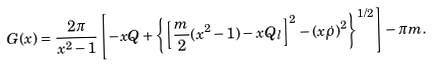Convert formula to latex. <formula><loc_0><loc_0><loc_500><loc_500>G ( x ) = \frac { 2 \pi } { x ^ { 2 } - 1 } \left [ - x Q + \left \{ \left [ \frac { m } { 2 } ( x ^ { 2 } - 1 ) - x Q _ { l } \right ] ^ { 2 } - ( x \dot { \rho } ) ^ { 2 } \right \} ^ { 1 / 2 } \right ] - \pi m .</formula> 